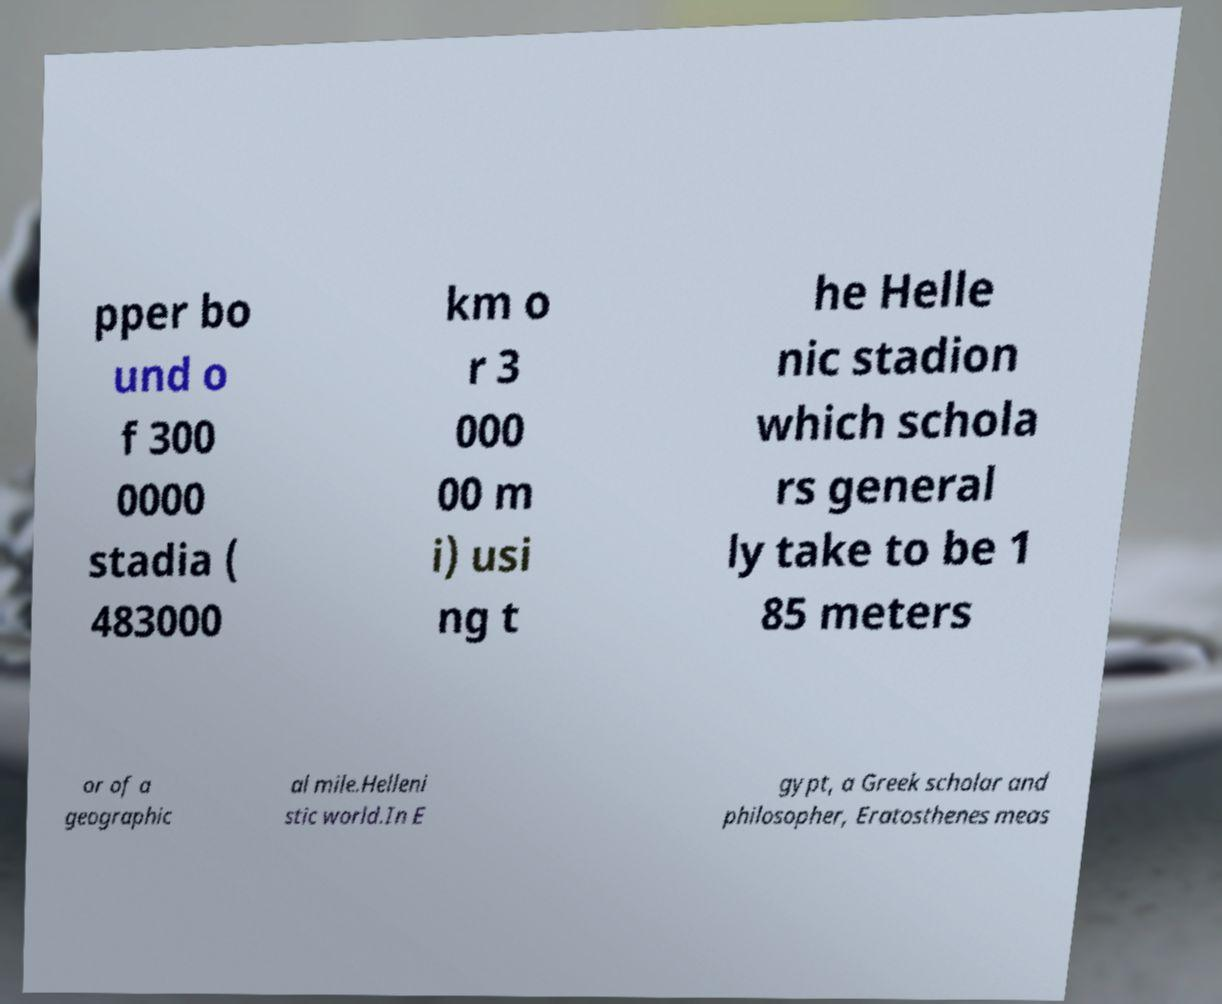I need the written content from this picture converted into text. Can you do that? pper bo und o f 300 0000 stadia ( 483000 km o r 3 000 00 m i) usi ng t he Helle nic stadion which schola rs general ly take to be 1 85 meters or of a geographic al mile.Helleni stic world.In E gypt, a Greek scholar and philosopher, Eratosthenes meas 